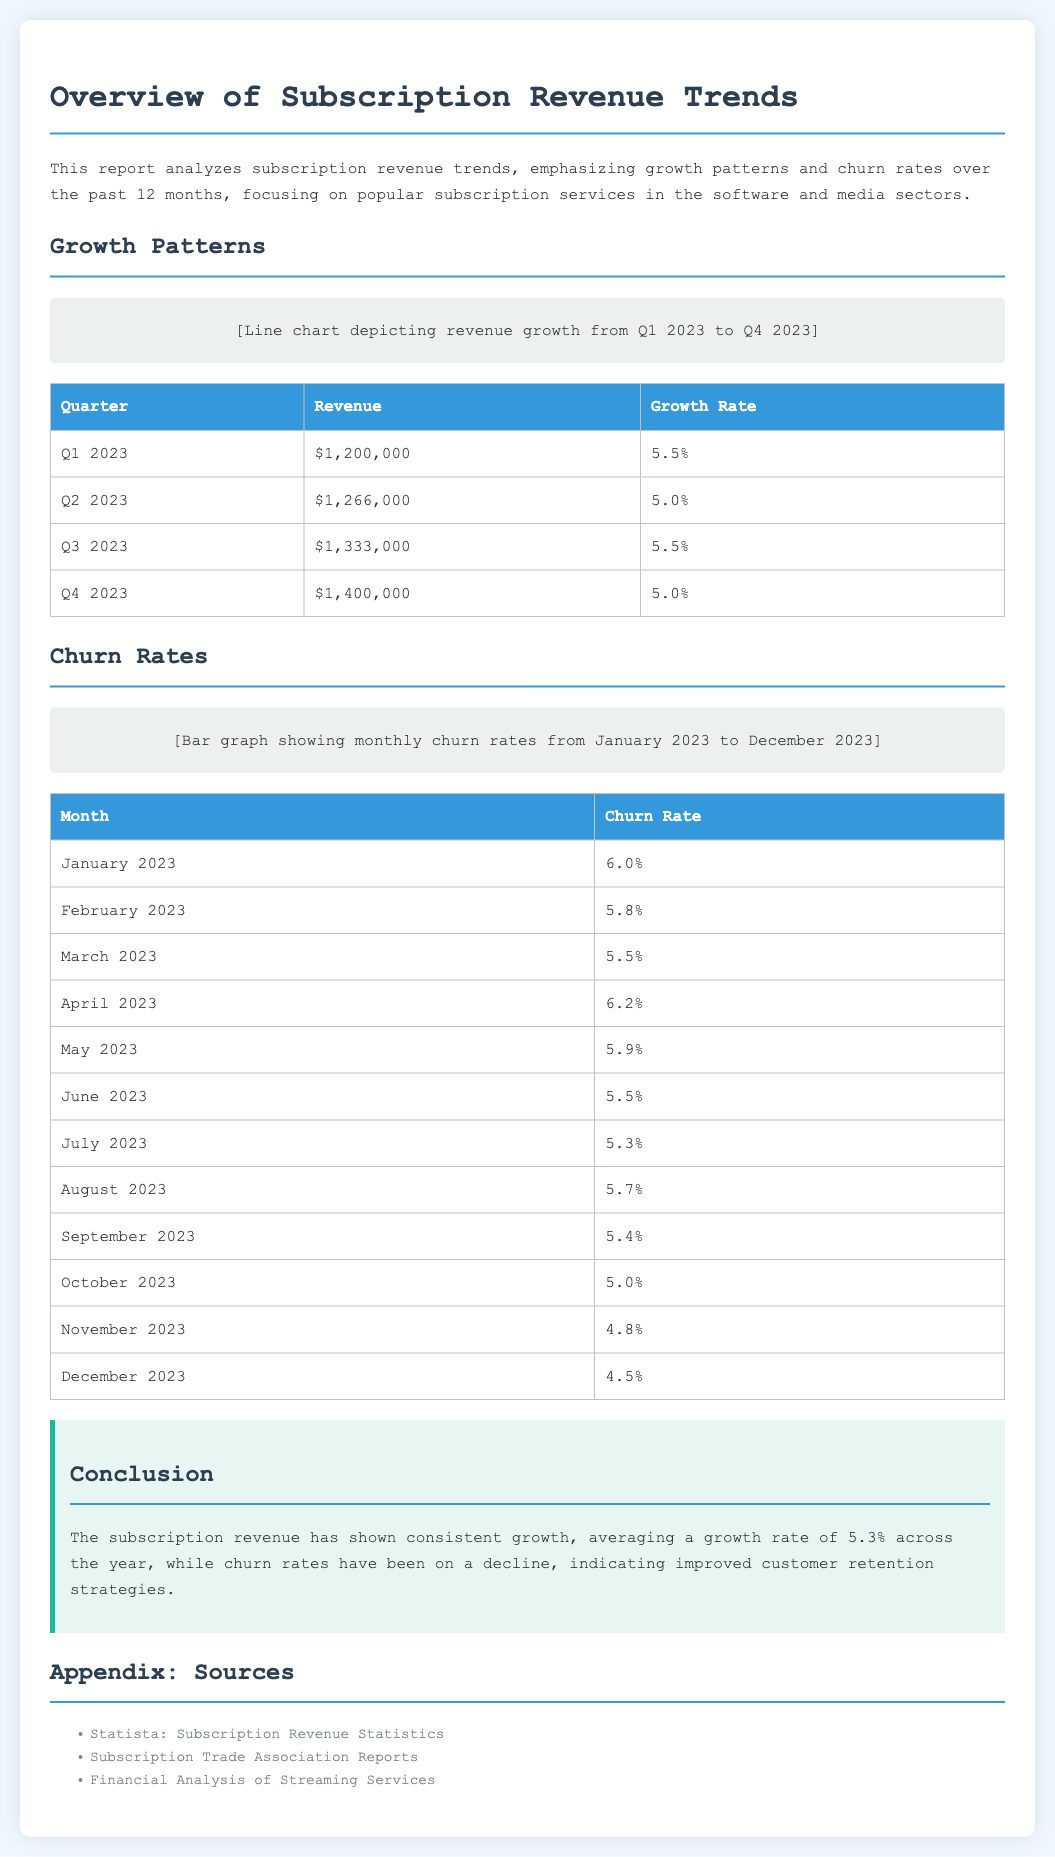What was the revenue in Q1 2023? The revenue in Q1 2023 is specifically stated in the document as $1,200,000.
Answer: $1,200,000 What is the average growth rate for the year? The average growth rate is calculated from the growth rates presented for each quarter, which is stated as 5.3%.
Answer: 5.3% What was the churn rate in December 2023? The document specifies the churn rate in December 2023 as 4.5%.
Answer: 4.5% How many months had a churn rate below 5%? By examining the churn rates for each month, it is noted that three months had a churn rate below 5%.
Answer: 3 months What was the highest revenue recorded in 2023? The highest revenue for 2023 is clearly indicated as $1,400,000 in Q4 2023.
Answer: $1,400,000 Which month had the highest churn rate? The document mentions that April 2023 had the highest churn rate at 6.2%.
Answer: April 2023 What percentage of churn rate was recorded in July 2023? The churn rate for July 2023 is explicitly mentioned as 5.3%.
Answer: 5.3% What is the purpose of this report? The purpose of the report is to analyze subscription revenue trends, focusing on growth patterns and churn rates.
Answer: Analyze subscription revenue trends What are the sources listed in the appendix? The sources are provided in the appendix section and include Statista, Subscription Trade Association Reports, and Financial Analysis of Streaming Services.
Answer: Statista, Subscription Trade Association Reports, Financial Analysis of Streaming Services 